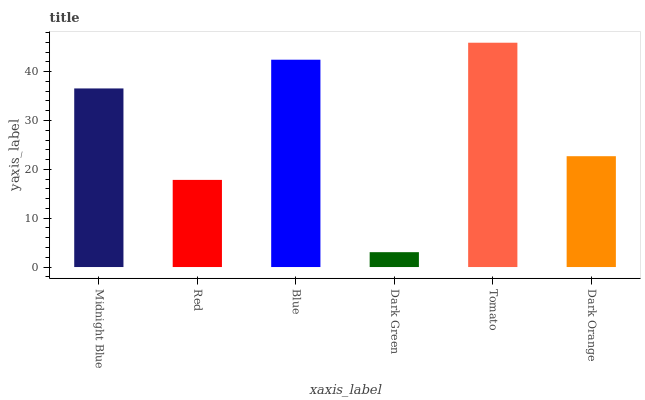Is Dark Green the minimum?
Answer yes or no. Yes. Is Tomato the maximum?
Answer yes or no. Yes. Is Red the minimum?
Answer yes or no. No. Is Red the maximum?
Answer yes or no. No. Is Midnight Blue greater than Red?
Answer yes or no. Yes. Is Red less than Midnight Blue?
Answer yes or no. Yes. Is Red greater than Midnight Blue?
Answer yes or no. No. Is Midnight Blue less than Red?
Answer yes or no. No. Is Midnight Blue the high median?
Answer yes or no. Yes. Is Dark Orange the low median?
Answer yes or no. Yes. Is Tomato the high median?
Answer yes or no. No. Is Blue the low median?
Answer yes or no. No. 